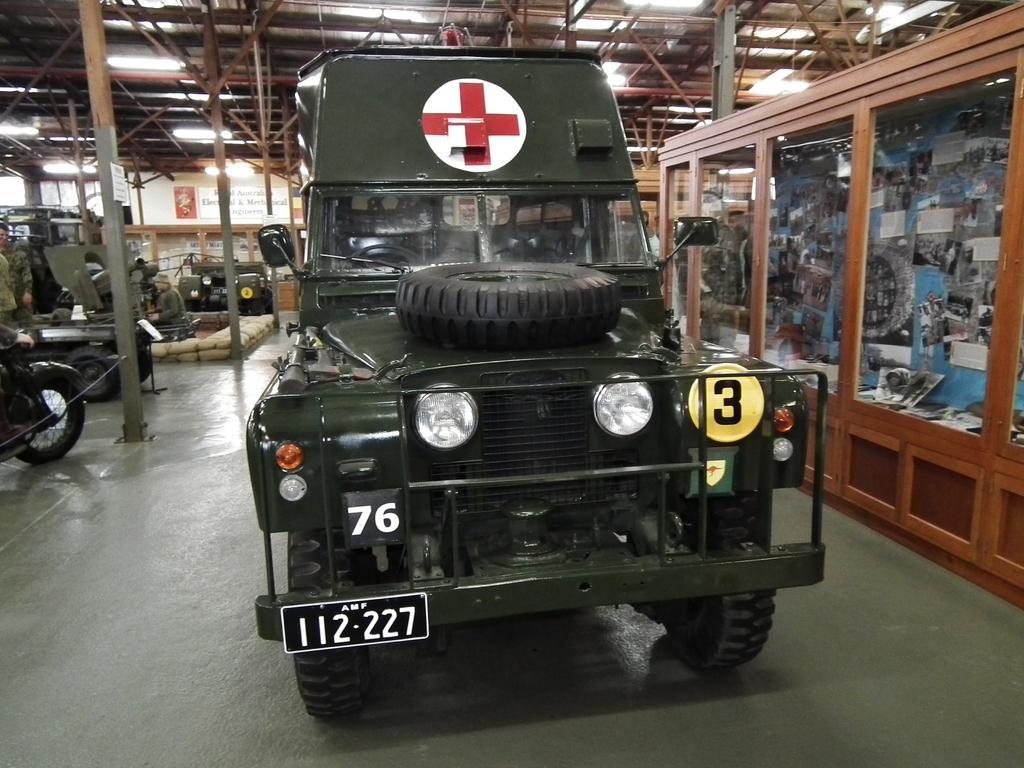Describe this image in one or two sentences. There is a vehicle with number plate. On the vehicle there is a tire. Also there are other numbers and there is a sign of first aid. On the right side there is a shelf. Inside that there are many items. On the left side there are many vehicles. Also there are poles. On the ceiling there are lights. 